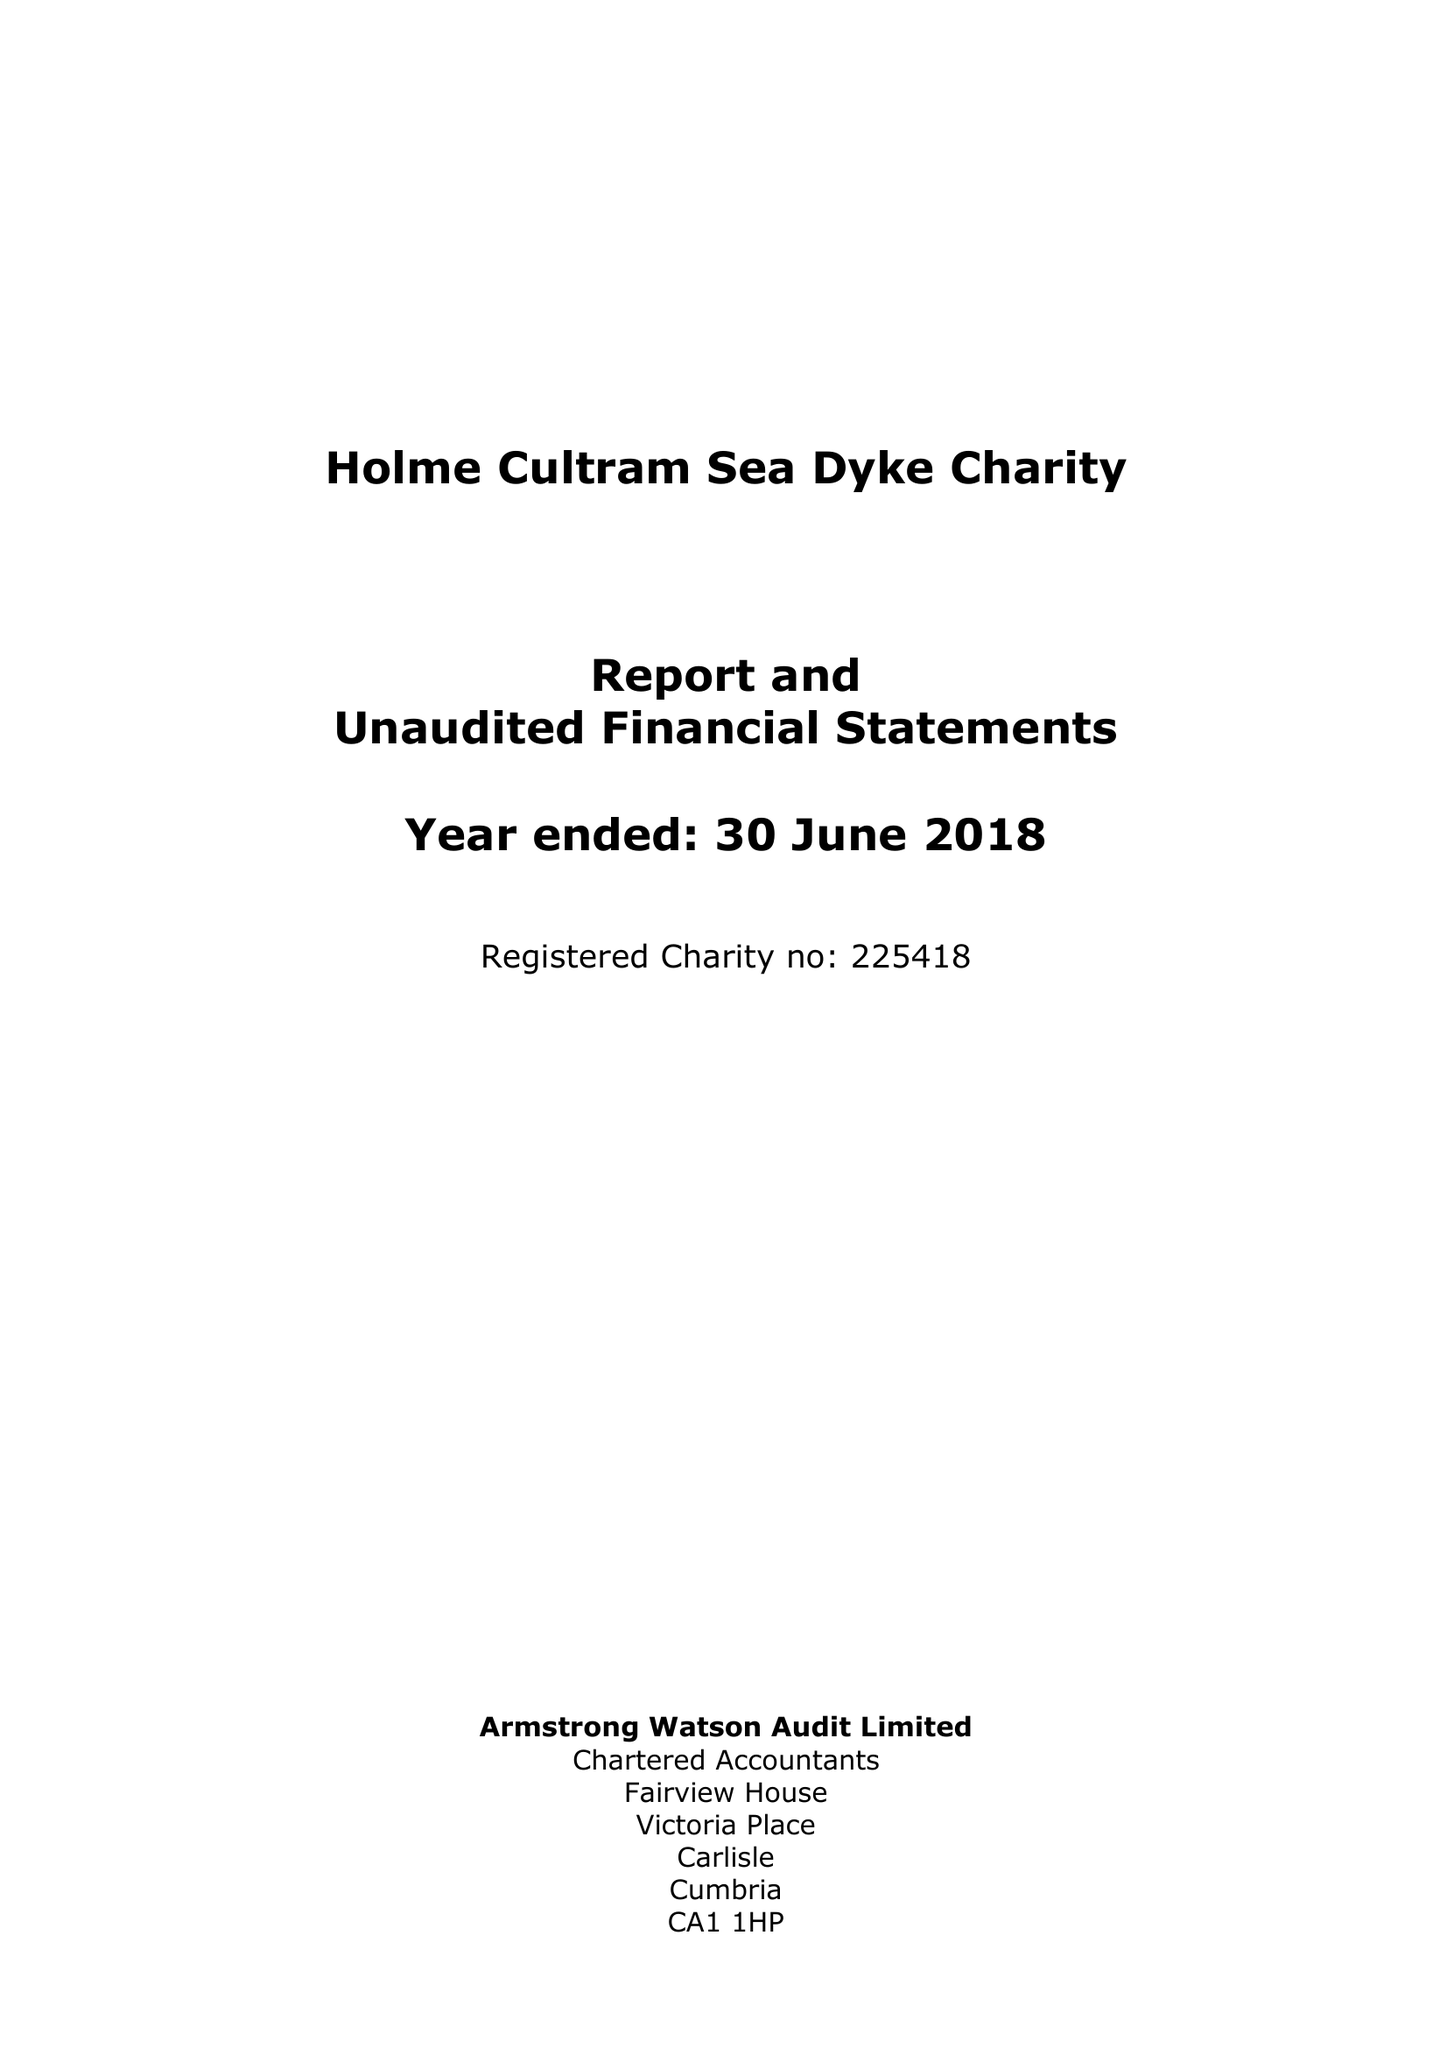What is the value for the address__post_town?
Answer the question using a single word or phrase. WIGTON 